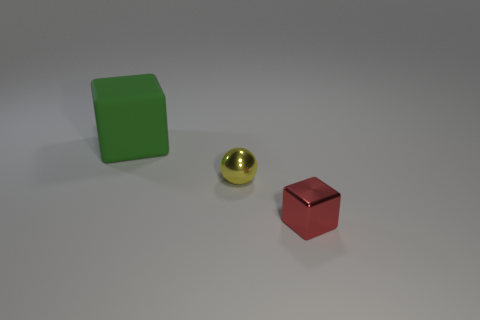Add 1 small blocks. How many objects exist? 4 Subtract all balls. How many objects are left? 2 Add 3 big purple metal cylinders. How many big purple metal cylinders exist? 3 Subtract 1 yellow spheres. How many objects are left? 2 Subtract all spheres. Subtract all red objects. How many objects are left? 1 Add 3 green matte objects. How many green matte objects are left? 4 